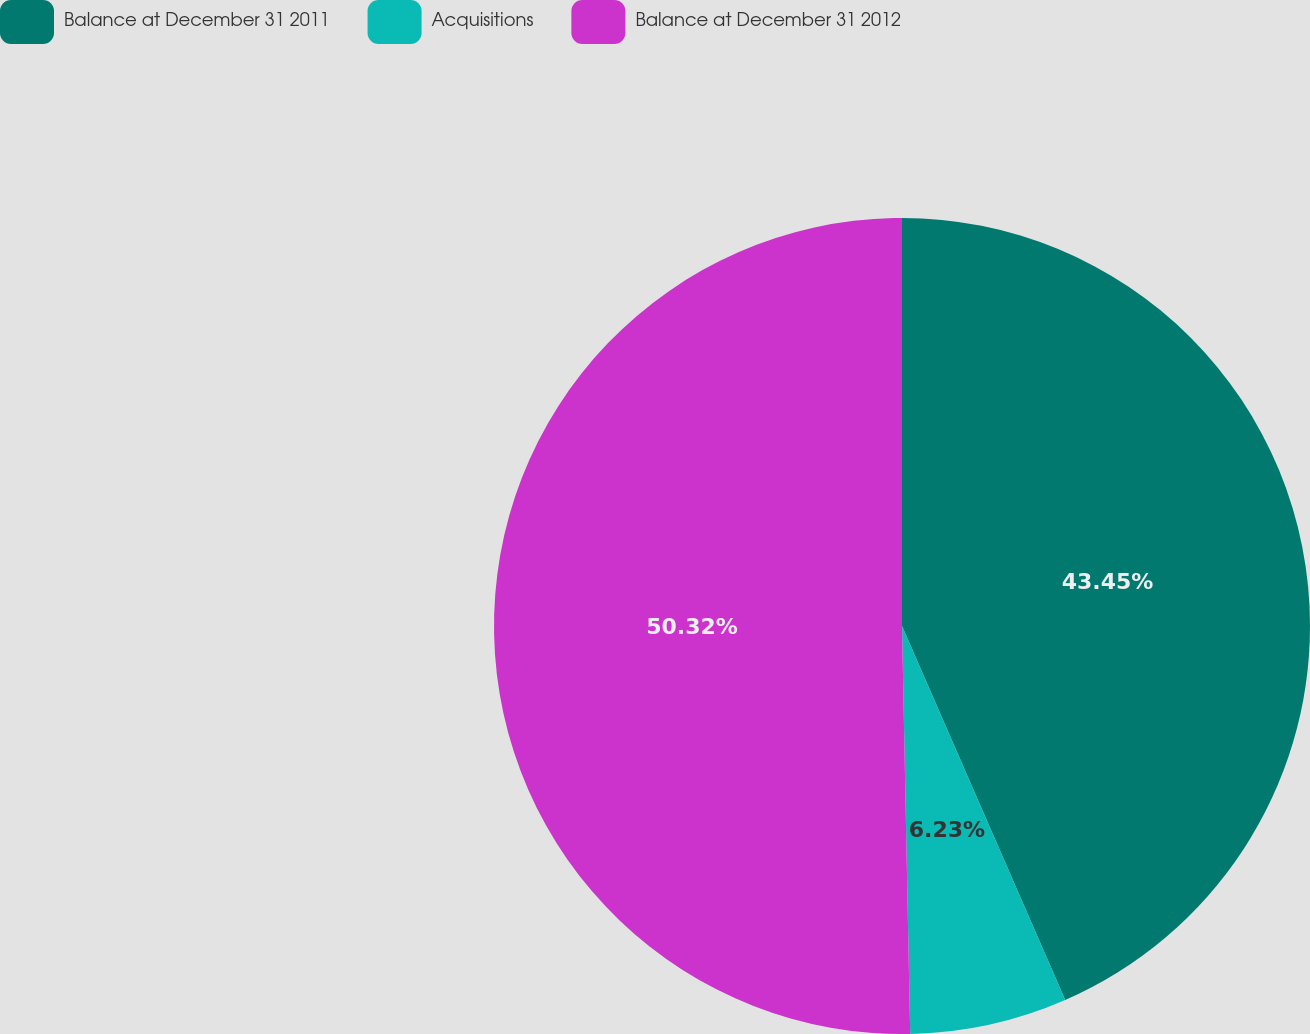Convert chart. <chart><loc_0><loc_0><loc_500><loc_500><pie_chart><fcel>Balance at December 31 2011<fcel>Acquisitions<fcel>Balance at December 31 2012<nl><fcel>43.45%<fcel>6.23%<fcel>50.32%<nl></chart> 